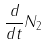Convert formula to latex. <formula><loc_0><loc_0><loc_500><loc_500>\frac { d } { d t } N _ { 2 }</formula> 